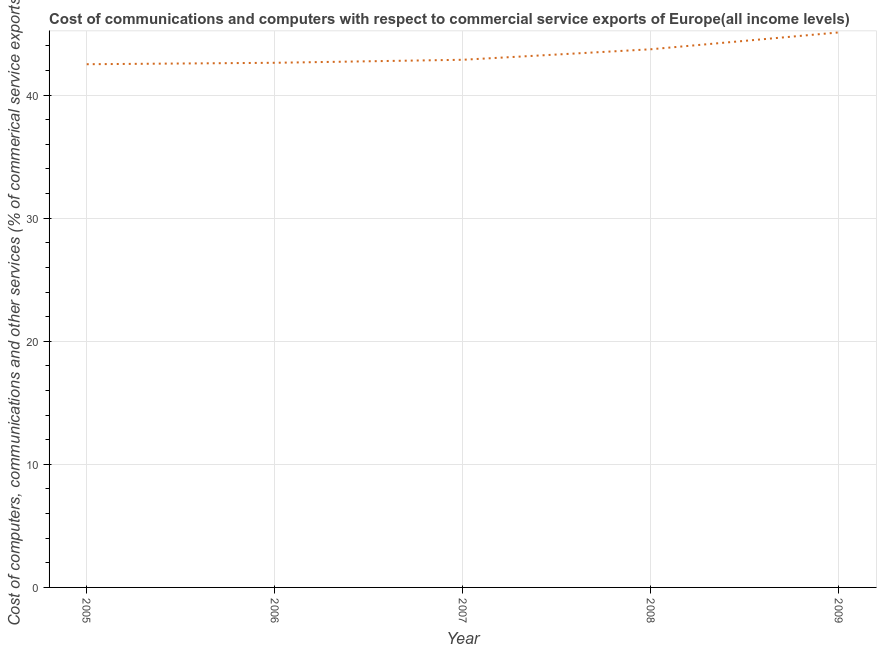What is the cost of communications in 2008?
Offer a very short reply. 43.72. Across all years, what is the maximum  computer and other services?
Your response must be concise. 45.09. Across all years, what is the minimum  computer and other services?
Your answer should be compact. 42.51. In which year was the  computer and other services minimum?
Offer a very short reply. 2005. What is the sum of the cost of communications?
Your answer should be compact. 216.81. What is the difference between the  computer and other services in 2005 and 2007?
Your answer should be compact. -0.36. What is the average cost of communications per year?
Make the answer very short. 43.36. What is the median cost of communications?
Ensure brevity in your answer.  42.87. Do a majority of the years between 2006 and 2005 (inclusive) have cost of communications greater than 40 %?
Your response must be concise. No. What is the ratio of the cost of communications in 2006 to that in 2009?
Offer a very short reply. 0.95. What is the difference between the highest and the second highest  computer and other services?
Provide a succinct answer. 1.37. What is the difference between the highest and the lowest  computer and other services?
Your response must be concise. 2.58. How many lines are there?
Provide a succinct answer. 1. What is the difference between two consecutive major ticks on the Y-axis?
Provide a succinct answer. 10. Does the graph contain grids?
Give a very brief answer. Yes. What is the title of the graph?
Give a very brief answer. Cost of communications and computers with respect to commercial service exports of Europe(all income levels). What is the label or title of the X-axis?
Provide a short and direct response. Year. What is the label or title of the Y-axis?
Your response must be concise. Cost of computers, communications and other services (% of commerical service exports). What is the Cost of computers, communications and other services (% of commerical service exports) in 2005?
Give a very brief answer. 42.51. What is the Cost of computers, communications and other services (% of commerical service exports) of 2006?
Your response must be concise. 42.62. What is the Cost of computers, communications and other services (% of commerical service exports) in 2007?
Your response must be concise. 42.87. What is the Cost of computers, communications and other services (% of commerical service exports) in 2008?
Your answer should be compact. 43.72. What is the Cost of computers, communications and other services (% of commerical service exports) in 2009?
Give a very brief answer. 45.09. What is the difference between the Cost of computers, communications and other services (% of commerical service exports) in 2005 and 2006?
Keep it short and to the point. -0.12. What is the difference between the Cost of computers, communications and other services (% of commerical service exports) in 2005 and 2007?
Make the answer very short. -0.36. What is the difference between the Cost of computers, communications and other services (% of commerical service exports) in 2005 and 2008?
Offer a terse response. -1.22. What is the difference between the Cost of computers, communications and other services (% of commerical service exports) in 2005 and 2009?
Your answer should be very brief. -2.58. What is the difference between the Cost of computers, communications and other services (% of commerical service exports) in 2006 and 2007?
Ensure brevity in your answer.  -0.24. What is the difference between the Cost of computers, communications and other services (% of commerical service exports) in 2006 and 2008?
Offer a terse response. -1.1. What is the difference between the Cost of computers, communications and other services (% of commerical service exports) in 2006 and 2009?
Your response must be concise. -2.47. What is the difference between the Cost of computers, communications and other services (% of commerical service exports) in 2007 and 2008?
Ensure brevity in your answer.  -0.85. What is the difference between the Cost of computers, communications and other services (% of commerical service exports) in 2007 and 2009?
Offer a terse response. -2.22. What is the difference between the Cost of computers, communications and other services (% of commerical service exports) in 2008 and 2009?
Give a very brief answer. -1.37. What is the ratio of the Cost of computers, communications and other services (% of commerical service exports) in 2005 to that in 2007?
Give a very brief answer. 0.99. What is the ratio of the Cost of computers, communications and other services (% of commerical service exports) in 2005 to that in 2008?
Provide a succinct answer. 0.97. What is the ratio of the Cost of computers, communications and other services (% of commerical service exports) in 2005 to that in 2009?
Offer a terse response. 0.94. What is the ratio of the Cost of computers, communications and other services (% of commerical service exports) in 2006 to that in 2009?
Make the answer very short. 0.94. What is the ratio of the Cost of computers, communications and other services (% of commerical service exports) in 2007 to that in 2009?
Your response must be concise. 0.95. 